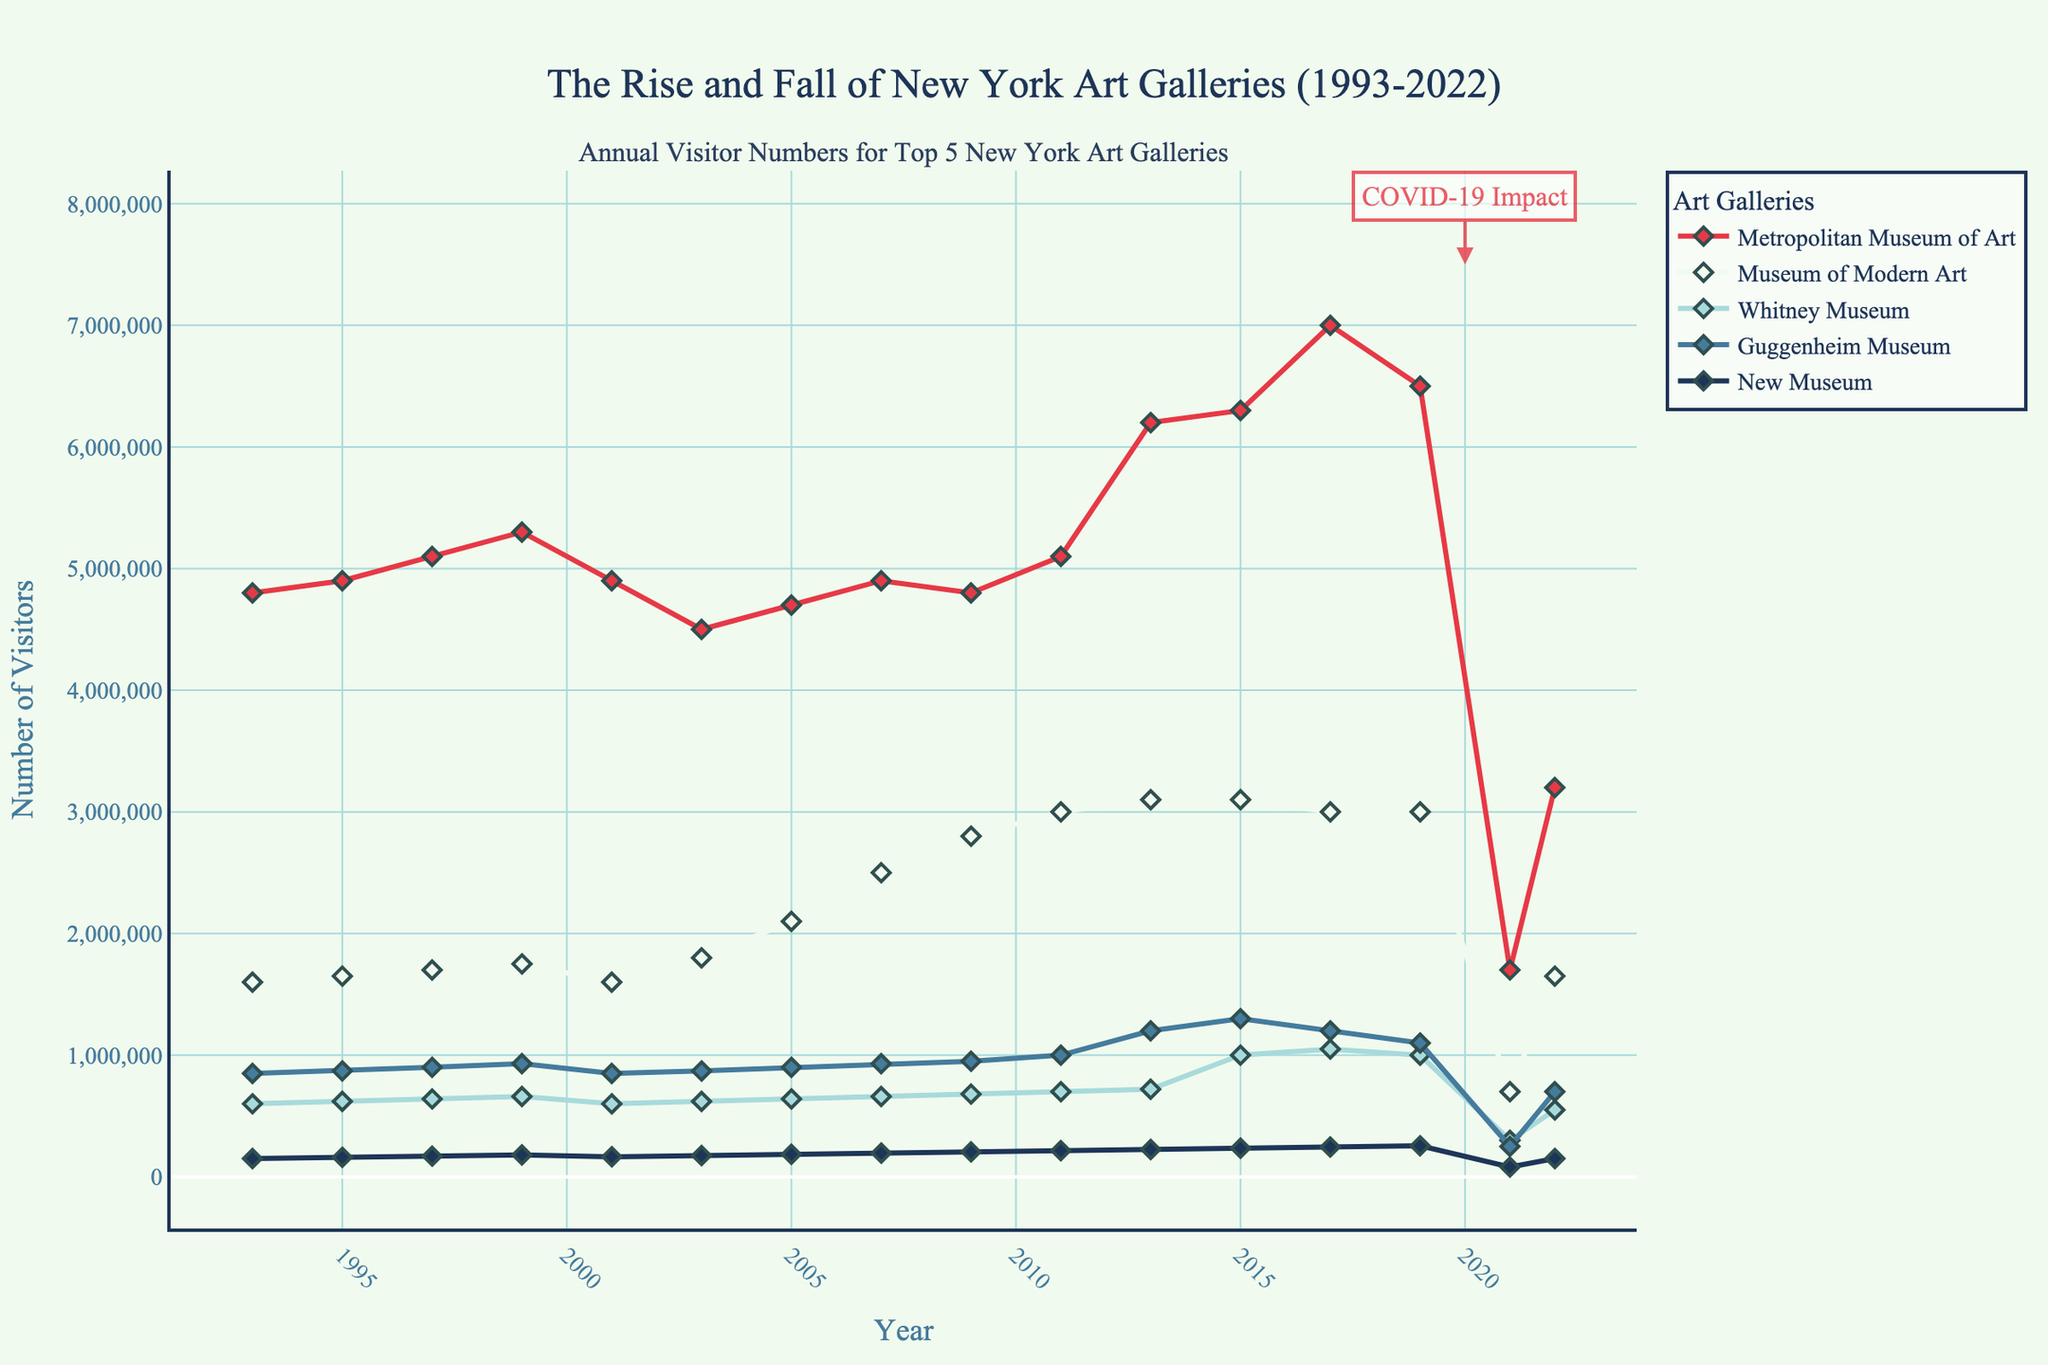What's the highest annual visitor number recorded by the Metropolitan Museum of Art, and in which year did it occur? The highest point on the line representing the Metropolitan Museum of Art shows around 7,000,000 visitors in 2017.
Answer: 2017, 7,000,000 Which museum had the lowest visitor numbers in 2021, and what was the number? The marker for 2021 shows that the New Museum had around 80,000 visitors, which is the lowest among the museums listed.
Answer: New Museum, 80,000 What was the approximate difference in visitor numbers between the Museum of Modern Art and the Guggenheim Museum in 2013? The visitor numbers for the Museum of Modern Art and the Guggenheim Museum in 2013 are about 3,100,000 and 1,200,000 respectively. The difference is approximately 3,100,000 - 1,200,000 = 1,900,000.
Answer: 1,900,000 Which museum showed the most dramatic drop in visitor numbers between 2019 and 2021? By visual inspection, the Metropolitan Museum of Art's line declines significantly from about 6,500,000 in 2019 to around 1,700,000 in 2021.
Answer: Metropolitan Museum of Art By how much did the visitor numbers at the Whitney Museum change from 1999 to 2015? The visitor numbers at the Whitney Museum are 660,000 in 1999 and 1,000,000 in 2015. The change is 1,000,000 - 660,000 = 340,000.
Answer: 340,000 On average, how many visitors did the New Museum receive annually from 1993 to 2022? Summing all the annual visitor numbers for the New Museum from 1993 to 2022 and dividing by the number of years (15) provides an average count. (150,000 + 160,000 + 170,000 + ... + 150,000) / 15 ≈ 169,333.33
Answer: ≈ 169,333 Compare the visitor trends of the Metropolitan Museum of Art and the Museum of Modern Art from 2001 to 2007. Which one shows more growth? Between 2001 and 2007, the Metropolitan Museum of Art goes from 4,900,000 to 4,900,000 (no change), while the Museum of Modern Art increases from 1,600,000 to 2,500,000. Thus, the Museum of Modern Art shows more growth.
Answer: Museum of Modern Art In which year did all the museums (most closely) experience an increase in visitor numbers following a significant drop? The year 2022 shows a recovery in visitor numbers for all museums following a significant drop in 2021, indicating recovery from the COVID-19 pandemic impact.
Answer: 2022 